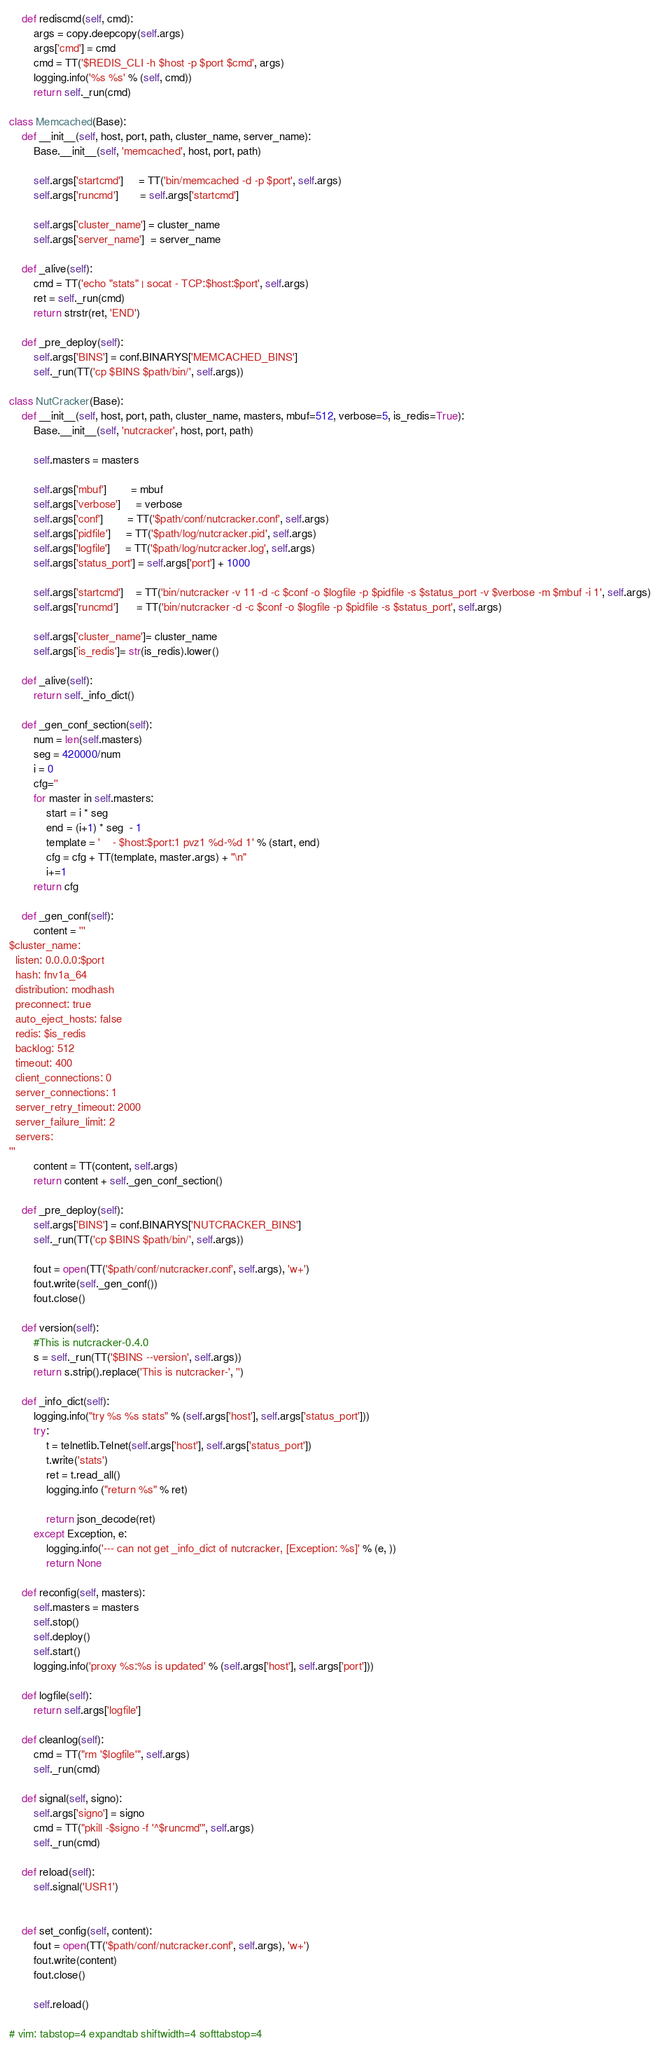Convert code to text. <code><loc_0><loc_0><loc_500><loc_500><_Python_>
    def rediscmd(self, cmd):
        args = copy.deepcopy(self.args)
        args['cmd'] = cmd
        cmd = TT('$REDIS_CLI -h $host -p $port $cmd', args)
        logging.info('%s %s' % (self, cmd))
        return self._run(cmd)

class Memcached(Base):
    def __init__(self, host, port, path, cluster_name, server_name):
        Base.__init__(self, 'memcached', host, port, path)

        self.args['startcmd']     = TT('bin/memcached -d -p $port', self.args)
        self.args['runcmd']       = self.args['startcmd']

        self.args['cluster_name'] = cluster_name
        self.args['server_name']  = server_name

    def _alive(self):
        cmd = TT('echo "stats" | socat - TCP:$host:$port', self.args)
        ret = self._run(cmd)
        return strstr(ret, 'END')

    def _pre_deploy(self):
        self.args['BINS'] = conf.BINARYS['MEMCACHED_BINS']
        self._run(TT('cp $BINS $path/bin/', self.args))

class NutCracker(Base):
    def __init__(self, host, port, path, cluster_name, masters, mbuf=512, verbose=5, is_redis=True):
        Base.__init__(self, 'nutcracker', host, port, path)

        self.masters = masters

        self.args['mbuf']        = mbuf
        self.args['verbose']     = verbose
        self.args['conf']        = TT('$path/conf/nutcracker.conf', self.args)
        self.args['pidfile']     = TT('$path/log/nutcracker.pid', self.args)
        self.args['logfile']     = TT('$path/log/nutcracker.log', self.args)
        self.args['status_port'] = self.args['port'] + 1000

        self.args['startcmd']    = TT('bin/nutcracker -v 11 -d -c $conf -o $logfile -p $pidfile -s $status_port -v $verbose -m $mbuf -i 1', self.args)
        self.args['runcmd']      = TT('bin/nutcracker -d -c $conf -o $logfile -p $pidfile -s $status_port', self.args)

        self.args['cluster_name']= cluster_name
        self.args['is_redis']= str(is_redis).lower()

    def _alive(self):
        return self._info_dict()

    def _gen_conf_section(self):
        num = len(self.masters)
        seg = 420000/num
        i = 0
        cfg=''
        for master in self.masters:
            start = i * seg  
            end = (i+1) * seg  - 1
            template = '    - $host:$port:1 pvz1 %d-%d 1' % (start, end)
            cfg = cfg + TT(template, master.args) + "\n"
            i+=1
        return cfg

    def _gen_conf(self):
        content = '''
$cluster_name:
  listen: 0.0.0.0:$port
  hash: fnv1a_64
  distribution: modhash
  preconnect: true
  auto_eject_hosts: false
  redis: $is_redis
  backlog: 512
  timeout: 400
  client_connections: 0
  server_connections: 1
  server_retry_timeout: 2000
  server_failure_limit: 2
  servers:
'''
        content = TT(content, self.args)
        return content + self._gen_conf_section()

    def _pre_deploy(self):
        self.args['BINS'] = conf.BINARYS['NUTCRACKER_BINS']
        self._run(TT('cp $BINS $path/bin/', self.args))

        fout = open(TT('$path/conf/nutcracker.conf', self.args), 'w+')
        fout.write(self._gen_conf())
        fout.close()

    def version(self):
        #This is nutcracker-0.4.0
        s = self._run(TT('$BINS --version', self.args))
        return s.strip().replace('This is nutcracker-', '')

    def _info_dict(self):
        logging.info("try %s %s stats" % (self.args['host'], self.args['status_port']))
        try:
            t = telnetlib.Telnet(self.args['host'], self.args['status_port'])
            t.write('stats')
            ret = t.read_all()
            logging.info ("return %s" % ret)
            
            return json_decode(ret)
        except Exception, e:
            logging.info('--- can not get _info_dict of nutcracker, [Exception: %s]' % (e, ))
            return None

    def reconfig(self, masters):
        self.masters = masters
        self.stop()
        self.deploy()
        self.start()
        logging.info('proxy %s:%s is updated' % (self.args['host'], self.args['port']))

    def logfile(self):
        return self.args['logfile']

    def cleanlog(self):
        cmd = TT("rm '$logfile'", self.args)
        self._run(cmd)

    def signal(self, signo):
        self.args['signo'] = signo
        cmd = TT("pkill -$signo -f '^$runcmd'", self.args)
        self._run(cmd)

    def reload(self):
        self.signal('USR1')


    def set_config(self, content):
        fout = open(TT('$path/conf/nutcracker.conf', self.args), 'w+')
        fout.write(content)
        fout.close()

        self.reload()

# vim: tabstop=4 expandtab shiftwidth=4 softtabstop=4

</code> 